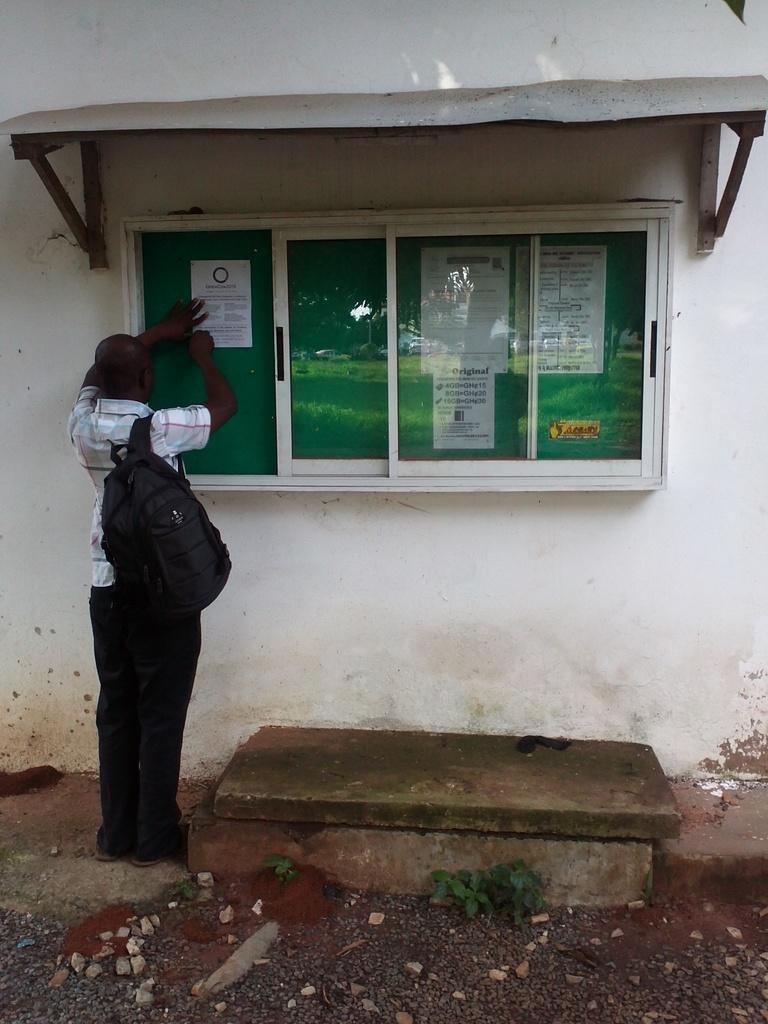Could you give a brief overview of what you see in this image? In this picture we can see plants, stones on the ground and a person carrying a bag. In front of this person we can see posts on a board, wall, sun shade and some objects. 